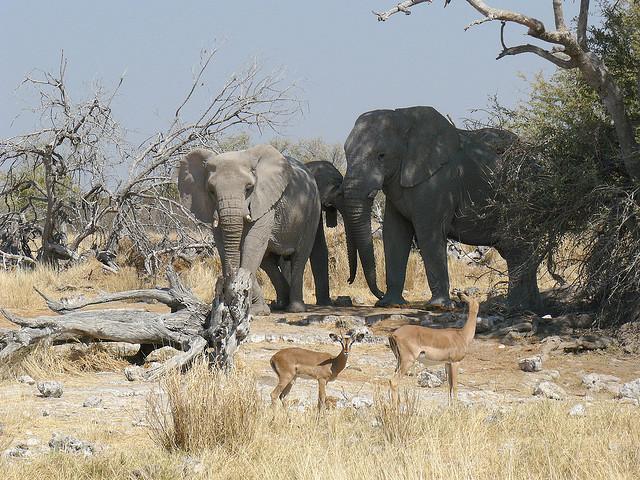How many elephants are there?
Give a very brief answer. 2. How many elephants?
Give a very brief answer. 2. How many dogs are pictured on the side of the bus?
Give a very brief answer. 0. 